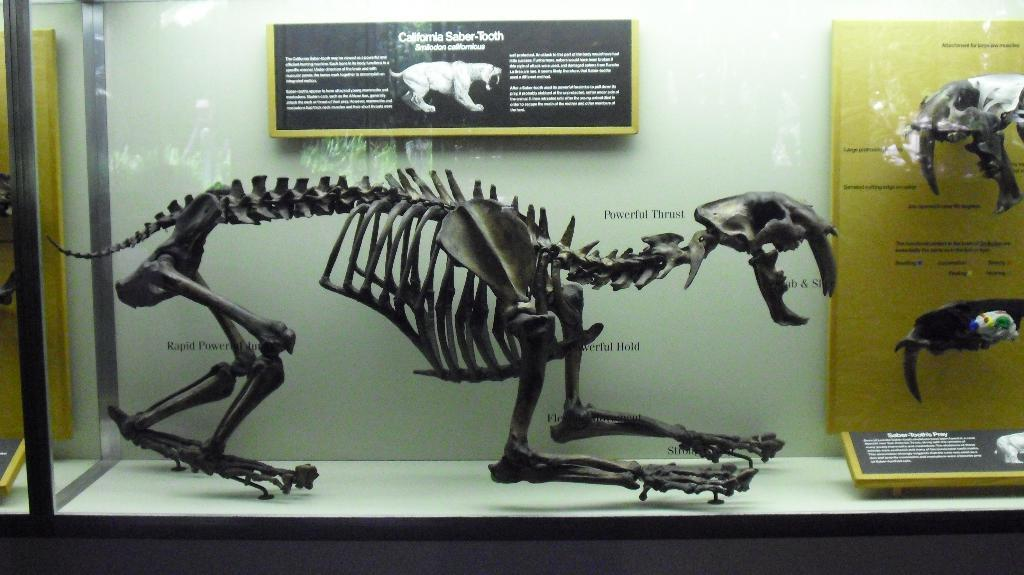What is the main subject of the image? The main subject of the image is the bones of an animal. How are the bones displayed in the image? The bones are placed in a glass container. What can be seen in the background of the image? There is a board and a wall in the background of the image. What type of grass is growing on the scale in the image? There is no grass or scale present in the image; it features bones of an animal in a glass container with a board and a wall in the background. 